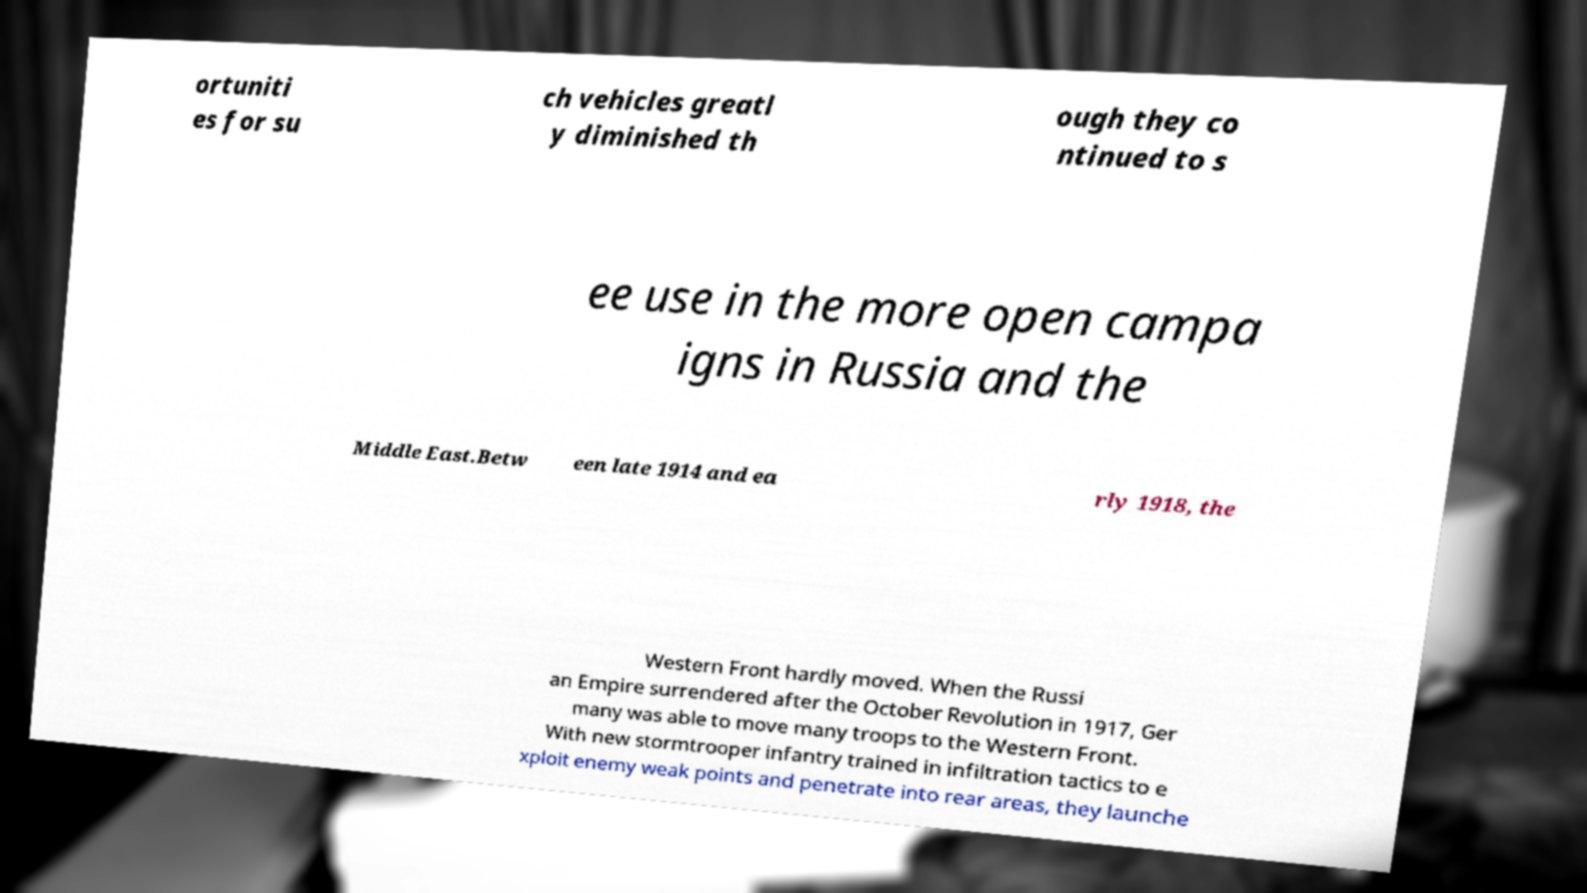What messages or text are displayed in this image? I need them in a readable, typed format. ortuniti es for su ch vehicles greatl y diminished th ough they co ntinued to s ee use in the more open campa igns in Russia and the Middle East.Betw een late 1914 and ea rly 1918, the Western Front hardly moved. When the Russi an Empire surrendered after the October Revolution in 1917, Ger many was able to move many troops to the Western Front. With new stormtrooper infantry trained in infiltration tactics to e xploit enemy weak points and penetrate into rear areas, they launche 